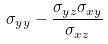<formula> <loc_0><loc_0><loc_500><loc_500>\sigma _ { y y } - \frac { \sigma _ { y z } \sigma _ { x y } } { \sigma _ { x z } }</formula> 